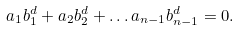Convert formula to latex. <formula><loc_0><loc_0><loc_500><loc_500>a _ { 1 } b _ { 1 } ^ { d } + a _ { 2 } b _ { 2 } ^ { d } + \dots a _ { n - 1 } b _ { n - 1 } ^ { d } = 0 .</formula> 